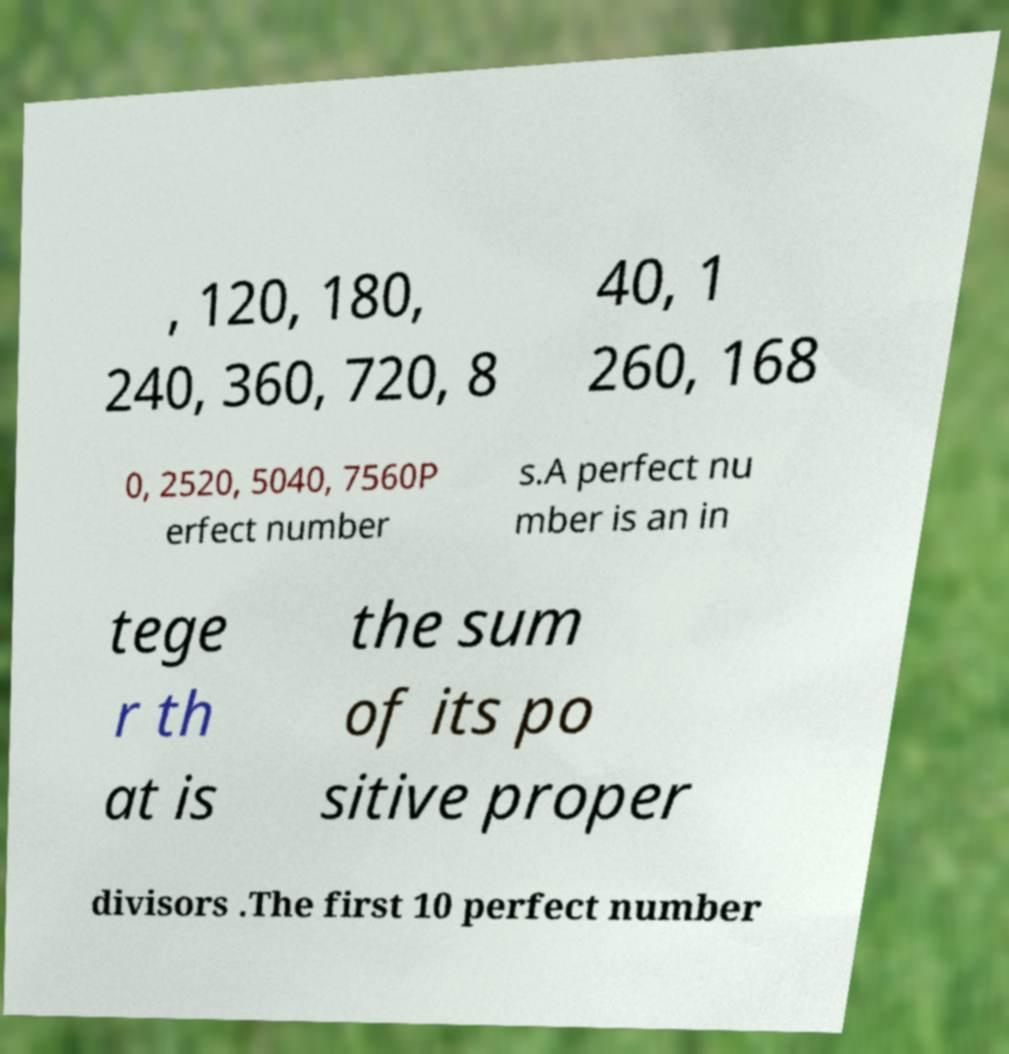For documentation purposes, I need the text within this image transcribed. Could you provide that? , 120, 180, 240, 360, 720, 8 40, 1 260, 168 0, 2520, 5040, 7560P erfect number s.A perfect nu mber is an in tege r th at is the sum of its po sitive proper divisors .The first 10 perfect number 